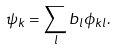<formula> <loc_0><loc_0><loc_500><loc_500>\psi _ { k } = \sum _ { l } b _ { l } \phi _ { k l } .</formula> 